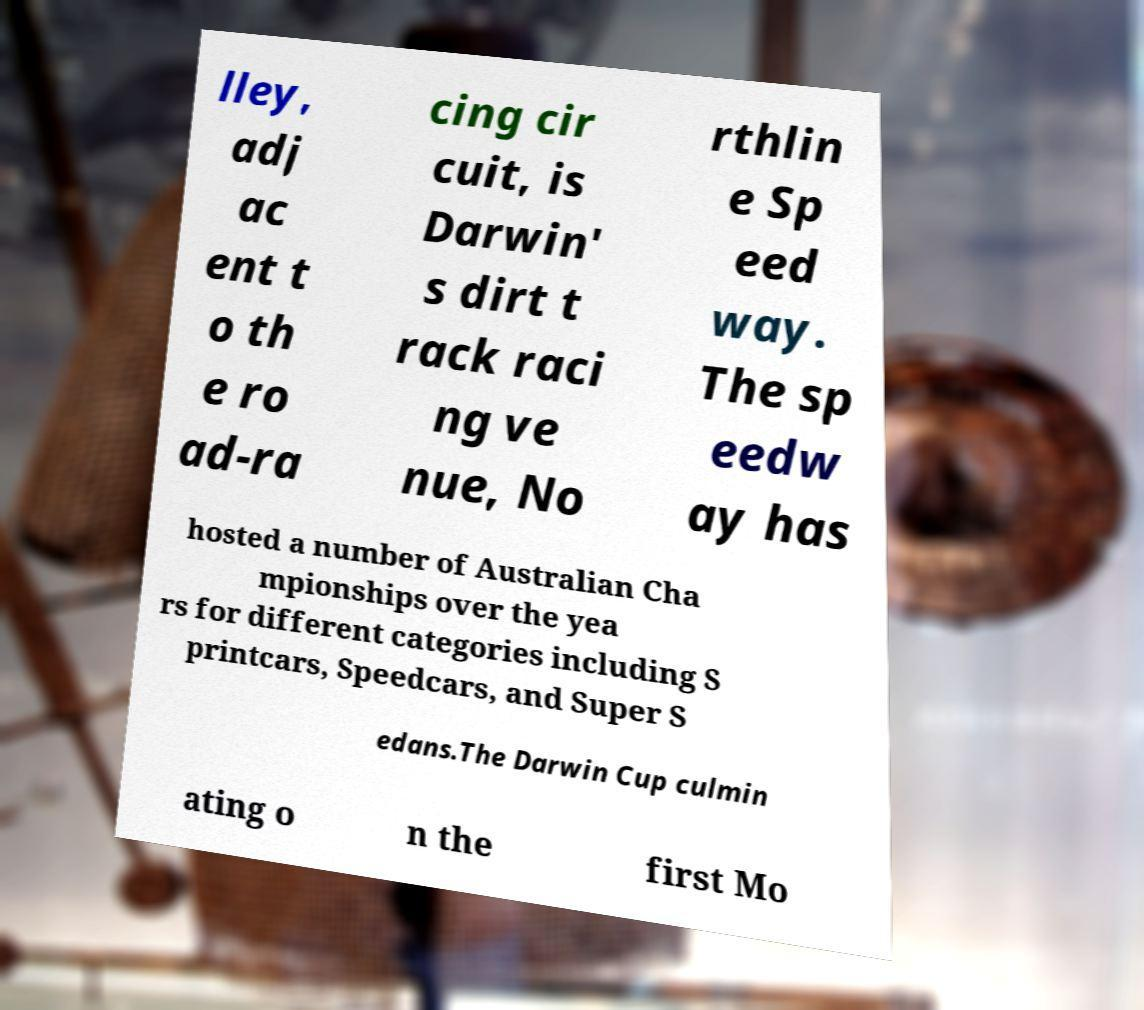Can you read and provide the text displayed in the image?This photo seems to have some interesting text. Can you extract and type it out for me? lley, adj ac ent t o th e ro ad-ra cing cir cuit, is Darwin' s dirt t rack raci ng ve nue, No rthlin e Sp eed way. The sp eedw ay has hosted a number of Australian Cha mpionships over the yea rs for different categories including S printcars, Speedcars, and Super S edans.The Darwin Cup culmin ating o n the first Mo 